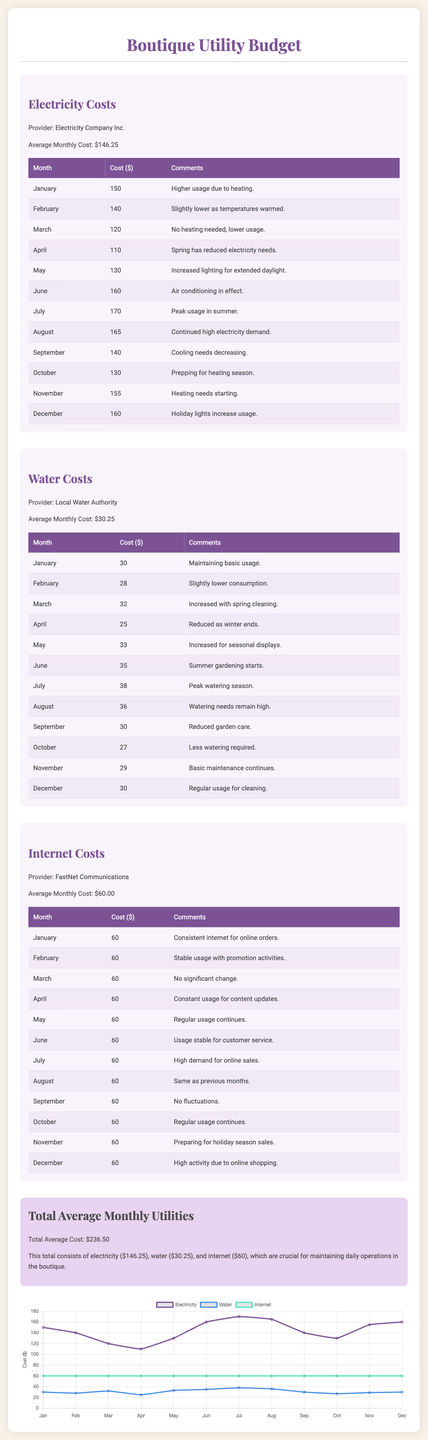What is the average monthly cost of electricity? The average monthly cost of electricity is stated directly in the document.
Answer: $146.25 What is the highest monthly water cost? The highest monthly water cost is found by reviewing the water costs listed for each month.
Answer: $38 Which month had the lowest electricity cost? The lowest electricity cost can be determined by comparing all monthly costs.
Answer: April How many months had a water cost above $30? This requires counting the number of months listed that are above $30 in the water costs.
Answer: 6 What is the provider of the internet service? The provider for the internet service is mentioned specifically in the respective section.
Answer: FastNet Communications What was the electricity cost in July? The electricity cost for July is stated directly in the document under the table.
Answer: $170 What is the total average monthly utility cost? The total average monthly utility cost is summarized at the end of the document.
Answer: $236.50 In which month did the water cost decrease the most compared to the previous month? This can be deduced by looking for the largest decrease in the water cost table.
Answer: April What percentage of the total average utility cost is attributed to electricity? This requires calculating what portion of the total average is represented by electricity.
Answer: 61.8% 